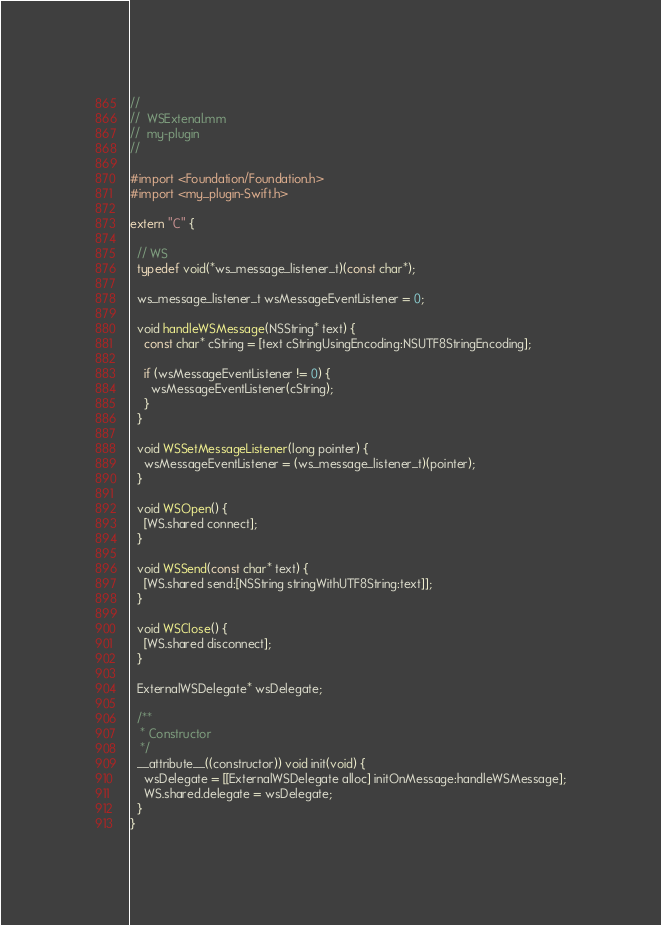Convert code to text. <code><loc_0><loc_0><loc_500><loc_500><_ObjectiveC_>//
//  WSExtenal.mm
//  my-plugin
//

#import <Foundation/Foundation.h>
#import <my_plugin-Swift.h>

extern "C" {
  
  // WS
  typedef void(*ws_message_listener_t)(const char*);
  
  ws_message_listener_t wsMessageEventListener = 0;
  
  void handleWSMessage(NSString* text) {
    const char* cString = [text cStringUsingEncoding:NSUTF8StringEncoding];
    
    if (wsMessageEventListener != 0) {
      wsMessageEventListener(cString);
    }
  }
  
  void WSSetMessageListener(long pointer) {
    wsMessageEventListener = (ws_message_listener_t)(pointer);
  }
  
  void WSOpen() {
    [WS.shared connect];
  }
  
  void WSSend(const char* text) {
    [WS.shared send:[NSString stringWithUTF8String:text]];
  }
  
  void WSClose() {
    [WS.shared disconnect];
  }
  
  ExternalWSDelegate* wsDelegate;
  
  /**
   * Constructor
   */
  __attribute__((constructor)) void init(void) {
    wsDelegate = [[ExternalWSDelegate alloc] initOnMessage:handleWSMessage];
    WS.shared.delegate = wsDelegate;
  }
}
</code> 